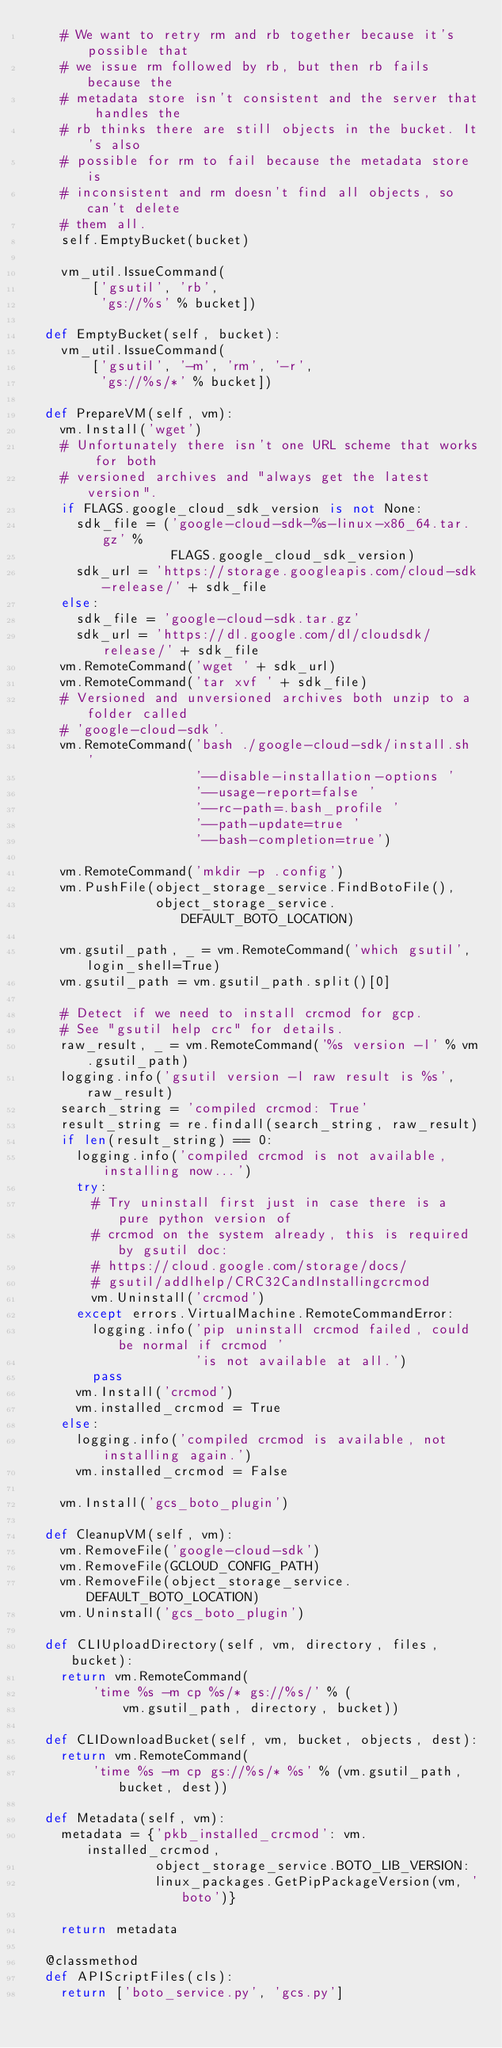<code> <loc_0><loc_0><loc_500><loc_500><_Python_>    # We want to retry rm and rb together because it's possible that
    # we issue rm followed by rb, but then rb fails because the
    # metadata store isn't consistent and the server that handles the
    # rb thinks there are still objects in the bucket. It's also
    # possible for rm to fail because the metadata store is
    # inconsistent and rm doesn't find all objects, so can't delete
    # them all.
    self.EmptyBucket(bucket)

    vm_util.IssueCommand(
        ['gsutil', 'rb',
         'gs://%s' % bucket])

  def EmptyBucket(self, bucket):
    vm_util.IssueCommand(
        ['gsutil', '-m', 'rm', '-r',
         'gs://%s/*' % bucket])

  def PrepareVM(self, vm):
    vm.Install('wget')
    # Unfortunately there isn't one URL scheme that works for both
    # versioned archives and "always get the latest version".
    if FLAGS.google_cloud_sdk_version is not None:
      sdk_file = ('google-cloud-sdk-%s-linux-x86_64.tar.gz' %
                  FLAGS.google_cloud_sdk_version)
      sdk_url = 'https://storage.googleapis.com/cloud-sdk-release/' + sdk_file
    else:
      sdk_file = 'google-cloud-sdk.tar.gz'
      sdk_url = 'https://dl.google.com/dl/cloudsdk/release/' + sdk_file
    vm.RemoteCommand('wget ' + sdk_url)
    vm.RemoteCommand('tar xvf ' + sdk_file)
    # Versioned and unversioned archives both unzip to a folder called
    # 'google-cloud-sdk'.
    vm.RemoteCommand('bash ./google-cloud-sdk/install.sh '
                     '--disable-installation-options '
                     '--usage-report=false '
                     '--rc-path=.bash_profile '
                     '--path-update=true '
                     '--bash-completion=true')

    vm.RemoteCommand('mkdir -p .config')
    vm.PushFile(object_storage_service.FindBotoFile(),
                object_storage_service.DEFAULT_BOTO_LOCATION)

    vm.gsutil_path, _ = vm.RemoteCommand('which gsutil', login_shell=True)
    vm.gsutil_path = vm.gsutil_path.split()[0]

    # Detect if we need to install crcmod for gcp.
    # See "gsutil help crc" for details.
    raw_result, _ = vm.RemoteCommand('%s version -l' % vm.gsutil_path)
    logging.info('gsutil version -l raw result is %s', raw_result)
    search_string = 'compiled crcmod: True'
    result_string = re.findall(search_string, raw_result)
    if len(result_string) == 0:
      logging.info('compiled crcmod is not available, installing now...')
      try:
        # Try uninstall first just in case there is a pure python version of
        # crcmod on the system already, this is required by gsutil doc:
        # https://cloud.google.com/storage/docs/
        # gsutil/addlhelp/CRC32CandInstallingcrcmod
        vm.Uninstall('crcmod')
      except errors.VirtualMachine.RemoteCommandError:
        logging.info('pip uninstall crcmod failed, could be normal if crcmod '
                     'is not available at all.')
        pass
      vm.Install('crcmod')
      vm.installed_crcmod = True
    else:
      logging.info('compiled crcmod is available, not installing again.')
      vm.installed_crcmod = False

    vm.Install('gcs_boto_plugin')

  def CleanupVM(self, vm):
    vm.RemoveFile('google-cloud-sdk')
    vm.RemoveFile(GCLOUD_CONFIG_PATH)
    vm.RemoveFile(object_storage_service.DEFAULT_BOTO_LOCATION)
    vm.Uninstall('gcs_boto_plugin')

  def CLIUploadDirectory(self, vm, directory, files, bucket):
    return vm.RemoteCommand(
        'time %s -m cp %s/* gs://%s/' % (
            vm.gsutil_path, directory, bucket))

  def CLIDownloadBucket(self, vm, bucket, objects, dest):
    return vm.RemoteCommand(
        'time %s -m cp gs://%s/* %s' % (vm.gsutil_path, bucket, dest))

  def Metadata(self, vm):
    metadata = {'pkb_installed_crcmod': vm.installed_crcmod,
                object_storage_service.BOTO_LIB_VERSION:
                linux_packages.GetPipPackageVersion(vm, 'boto')}

    return metadata

  @classmethod
  def APIScriptFiles(cls):
    return ['boto_service.py', 'gcs.py']
</code> 